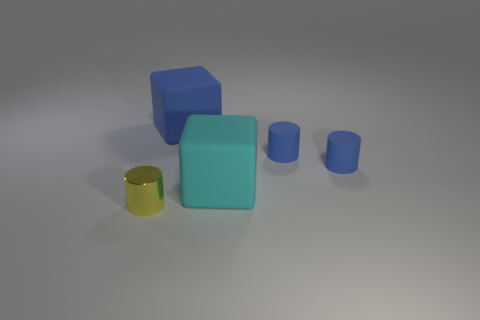How many objects are small cylinders behind the metal object or cubes that are behind the cyan rubber object? In the image, there are three small cylinders positioned behind the metallic object which appears to be a gold cylinder, and there are no cubes situated behind the cyan rubber object. This brings the total count of objects specified in the question to three small cylinders. 